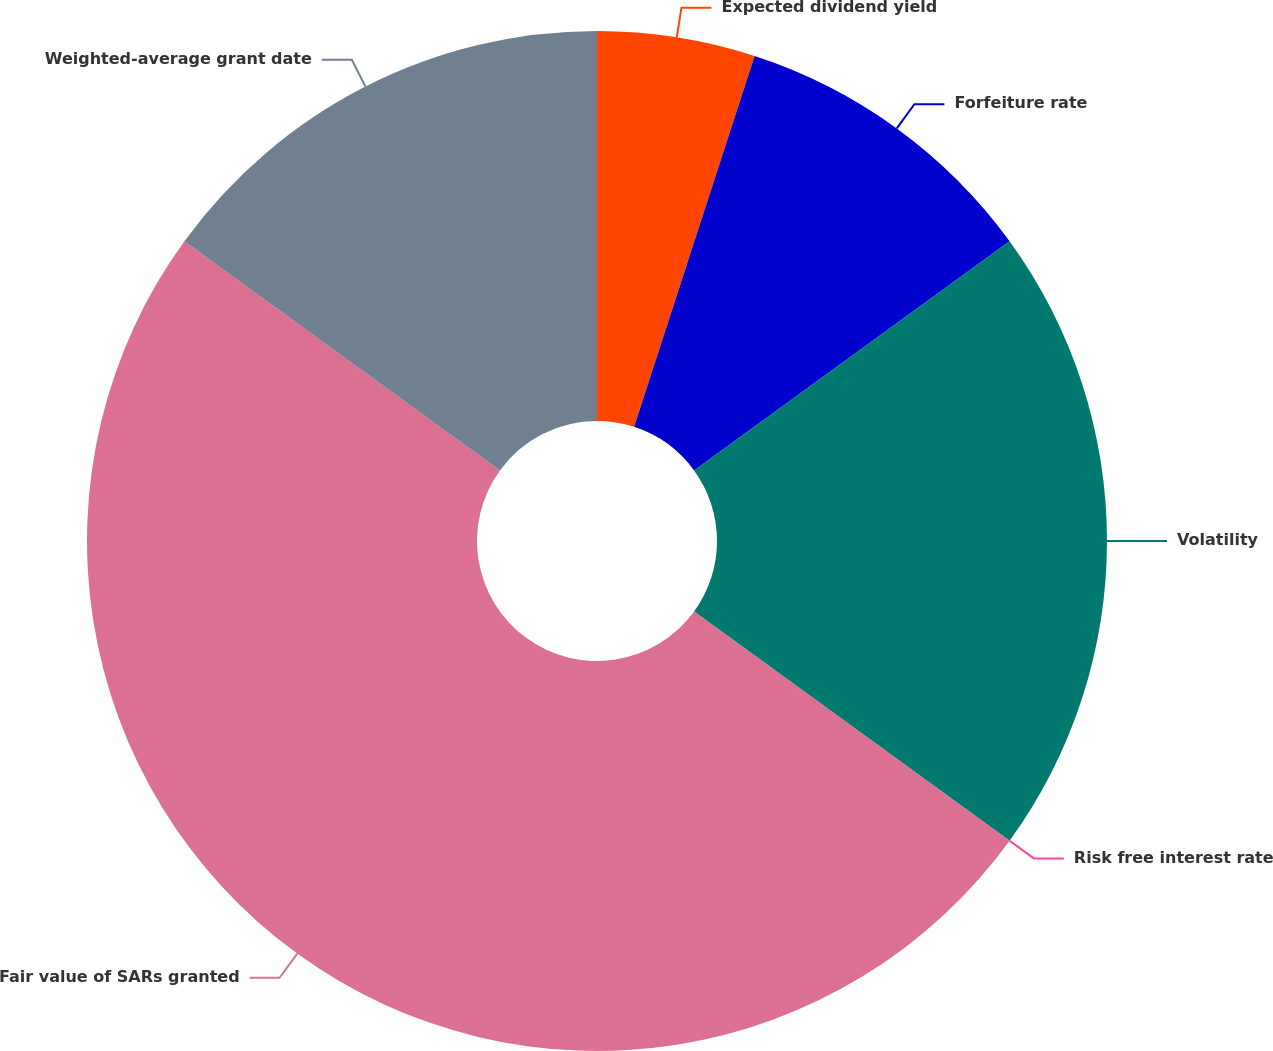Convert chart. <chart><loc_0><loc_0><loc_500><loc_500><pie_chart><fcel>Expected dividend yield<fcel>Forfeiture rate<fcel>Volatility<fcel>Risk free interest rate<fcel>Fair value of SARs granted<fcel>Weighted-average grant date<nl><fcel>5.0%<fcel>10.0%<fcel>20.0%<fcel>0.0%<fcel>50.0%<fcel>15.0%<nl></chart> 